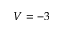Convert formula to latex. <formula><loc_0><loc_0><loc_500><loc_500>V = - 3</formula> 